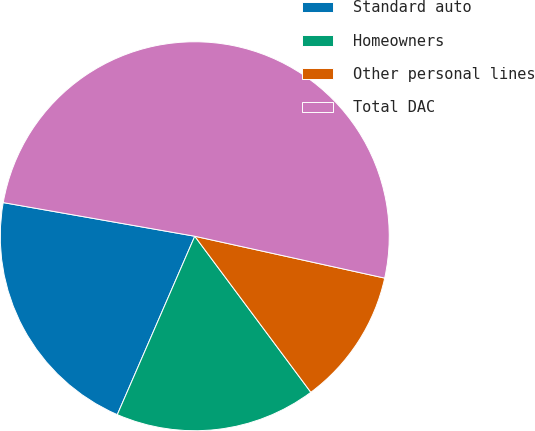Convert chart to OTSL. <chart><loc_0><loc_0><loc_500><loc_500><pie_chart><fcel>Standard auto<fcel>Homeowners<fcel>Other personal lines<fcel>Total DAC<nl><fcel>21.25%<fcel>16.7%<fcel>11.37%<fcel>50.69%<nl></chart> 